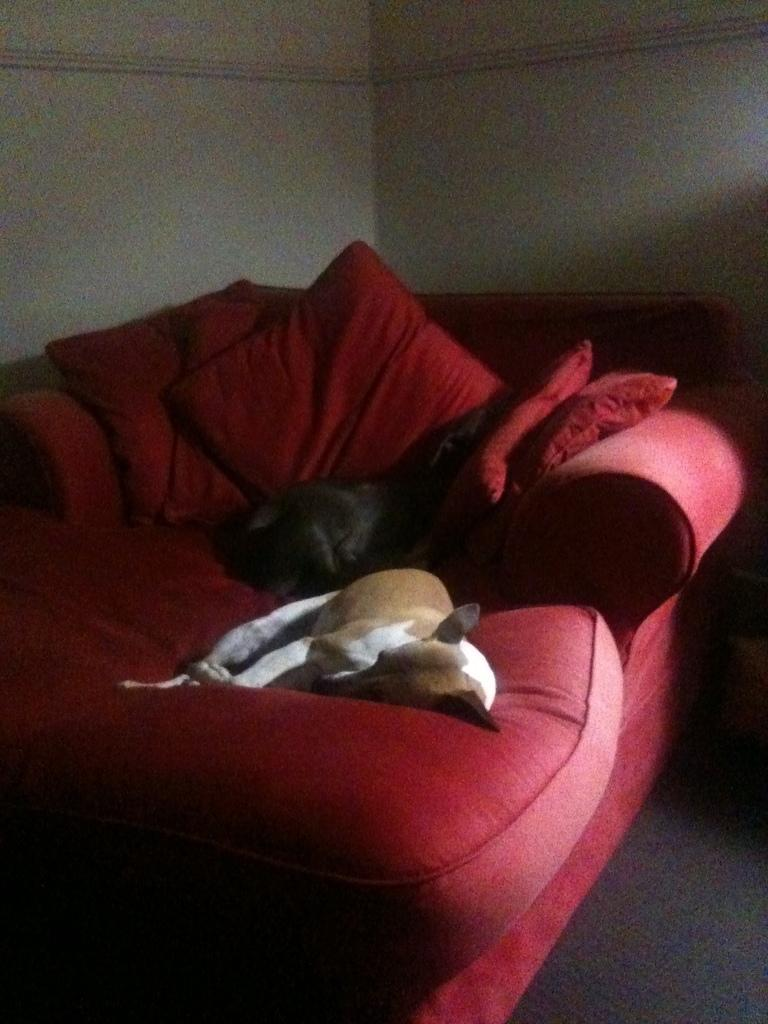What color is the couch in the image? The couch in the image is red. What is on the couch in the image? There are two dogs on the couch in the image. What else can be seen on the couch besides the dogs? There are pillows on the couch. What color is the wall in the background of the image? The wall in the background of the image is cream color. How many arches can be seen in the image? There are no arches present in the image. What type of apples are being served on the couch? There are no apples present in the image. 